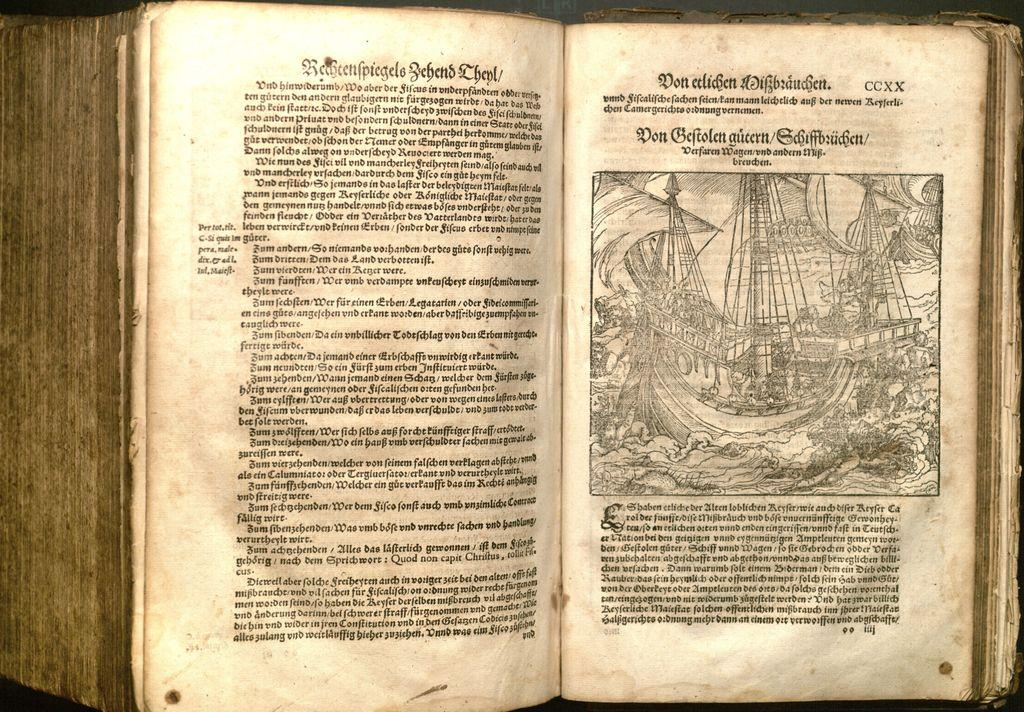<image>
Provide a brief description of the given image. Book open on a page that says CCXX on the top. 